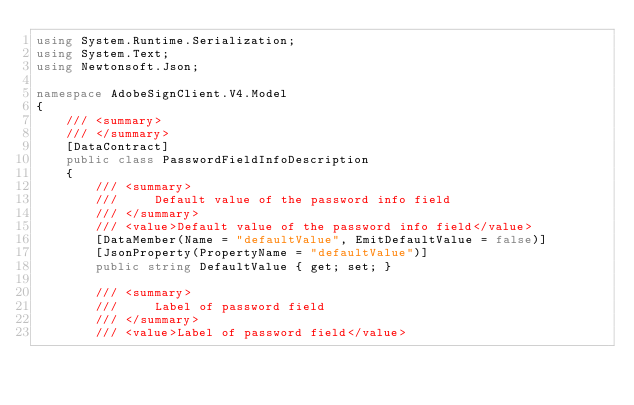Convert code to text. <code><loc_0><loc_0><loc_500><loc_500><_C#_>using System.Runtime.Serialization;
using System.Text;
using Newtonsoft.Json;

namespace AdobeSignClient.V4.Model
{
    /// <summary>
    /// </summary>
    [DataContract]
    public class PasswordFieldInfoDescription
    {
        /// <summary>
        ///     Default value of the password info field
        /// </summary>
        /// <value>Default value of the password info field</value>
        [DataMember(Name = "defaultValue", EmitDefaultValue = false)]
        [JsonProperty(PropertyName = "defaultValue")]
        public string DefaultValue { get; set; }

        /// <summary>
        ///     Label of password field
        /// </summary>
        /// <value>Label of password field</value></code> 